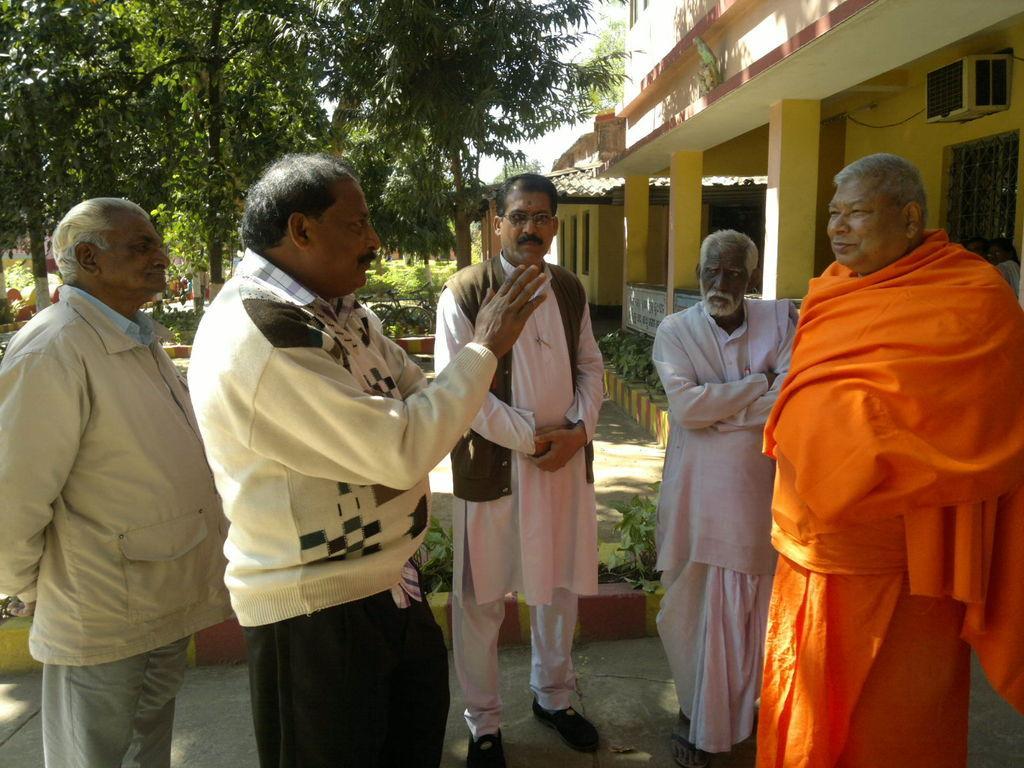How would you summarize this image in a sentence or two? In this picture I can see five persons standing, there are houses, plants, trees, and there is sky. 